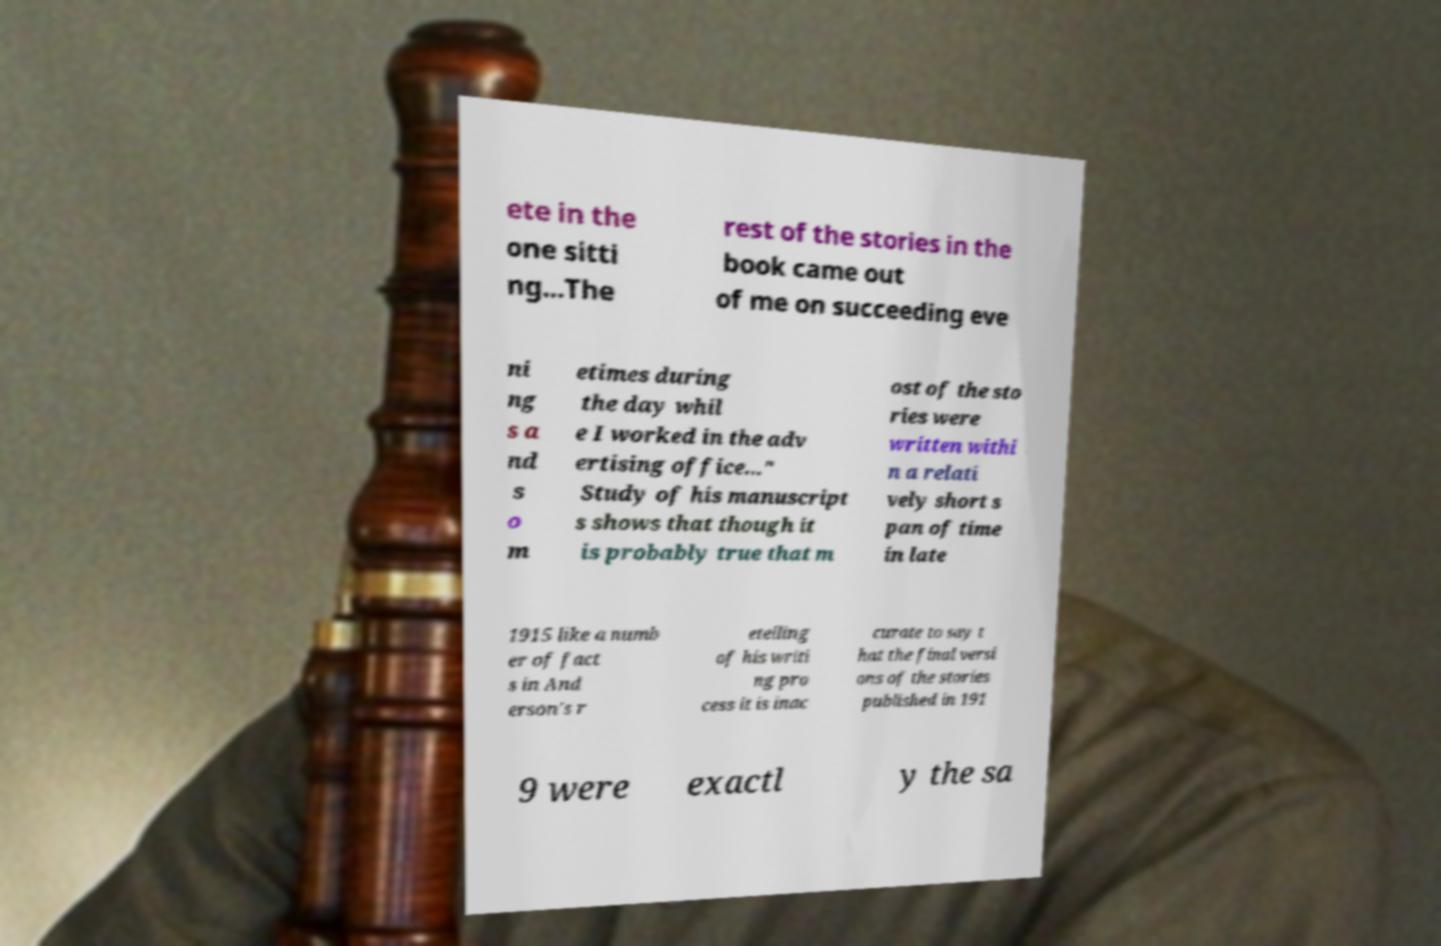Could you assist in decoding the text presented in this image and type it out clearly? ete in the one sitti ng...The rest of the stories in the book came out of me on succeeding eve ni ng s a nd s o m etimes during the day whil e I worked in the adv ertising office..." Study of his manuscript s shows that though it is probably true that m ost of the sto ries were written withi n a relati vely short s pan of time in late 1915 like a numb er of fact s in And erson's r etelling of his writi ng pro cess it is inac curate to say t hat the final versi ons of the stories published in 191 9 were exactl y the sa 